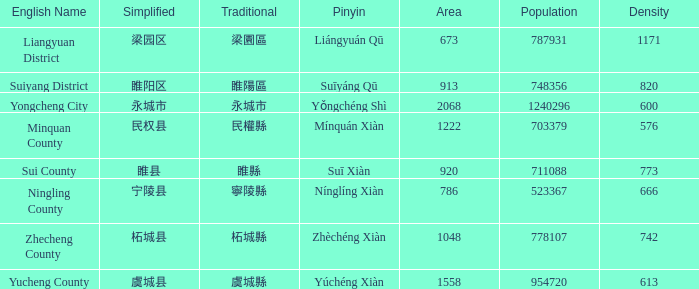Which traditional material has a density of 820? 睢陽區. 